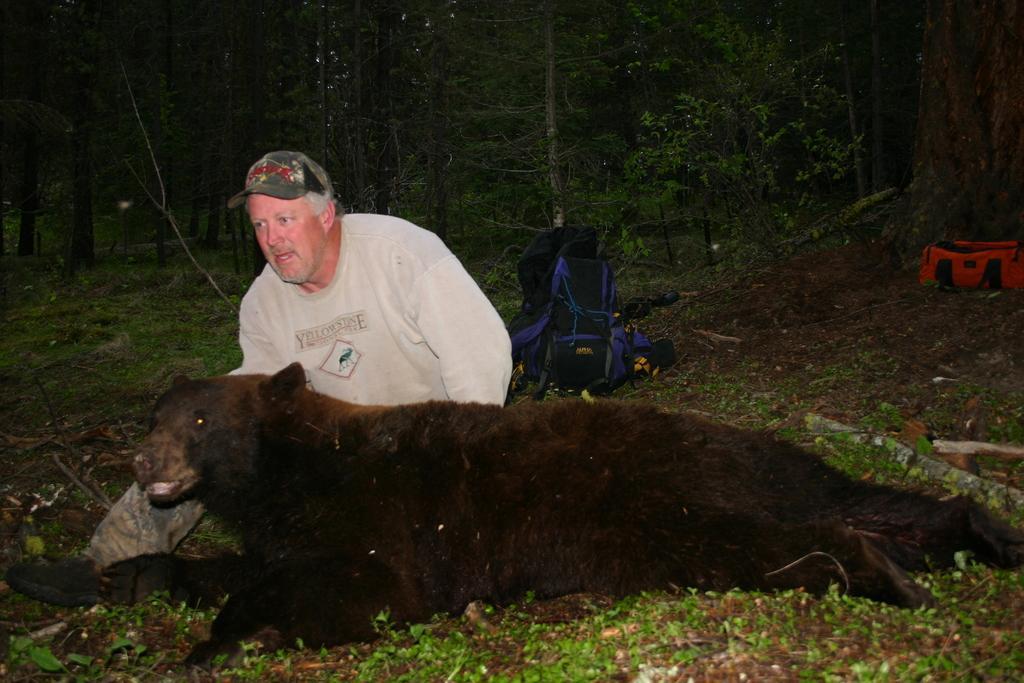Can you describe this image briefly? In this image we can see a bear. Also there is a person wearing cap. In the back there are bags. Also there are trees. 